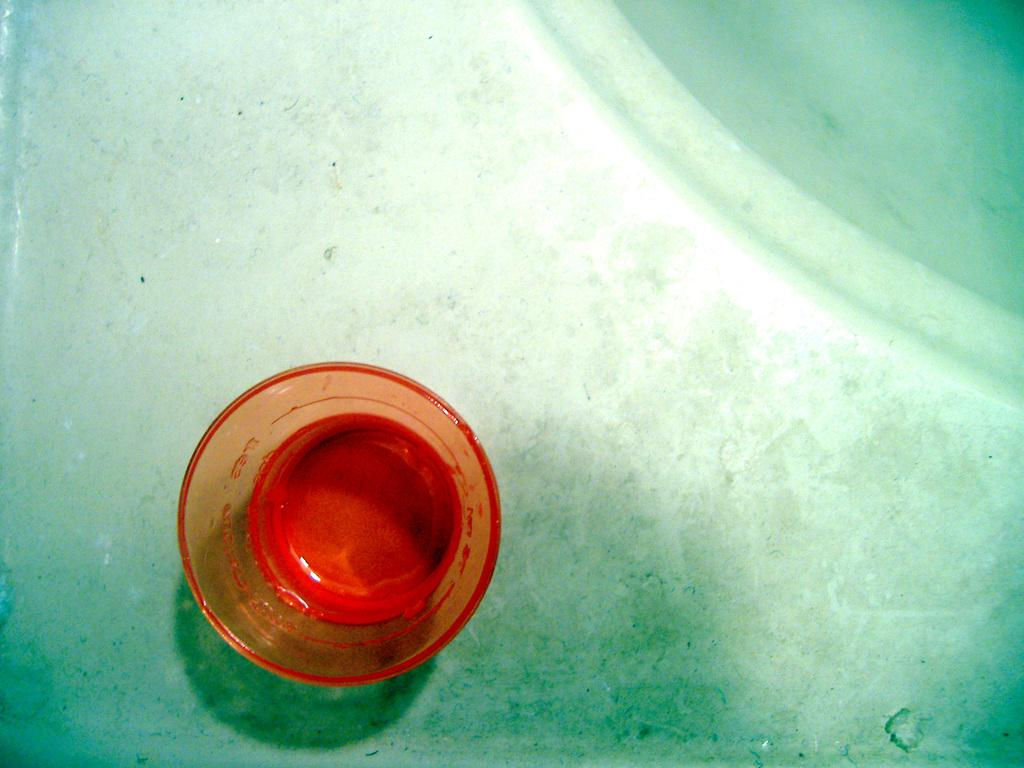What type of object is visible in the image? There is a glass object in the image. Where is the glass object located? The glass object is on a surface. What type of branch can be seen growing from the glass object in the image? There is no branch growing from the glass object in the image. 